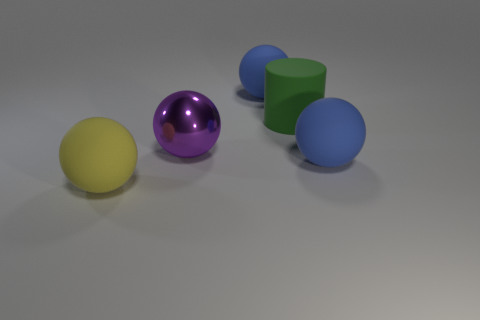Are there fewer balls that are in front of the big purple object than spheres that are right of the yellow matte sphere?
Give a very brief answer. Yes. What number of rubber things are blue blocks or purple things?
Keep it short and to the point. 0. There is a big yellow object; what shape is it?
Give a very brief answer. Sphere. What is the material of the other yellow thing that is the same size as the shiny object?
Your response must be concise. Rubber. How many tiny things are either blue matte balls or cylinders?
Your answer should be very brief. 0. Is there a small red metallic cube?
Provide a short and direct response. No. The green cylinder that is made of the same material as the yellow object is what size?
Your answer should be compact. Large. Is the cylinder made of the same material as the purple ball?
Your answer should be very brief. No. How many other things are the same material as the big green cylinder?
Offer a terse response. 3. What number of spheres are on the right side of the shiny ball and in front of the big purple ball?
Give a very brief answer. 1. 